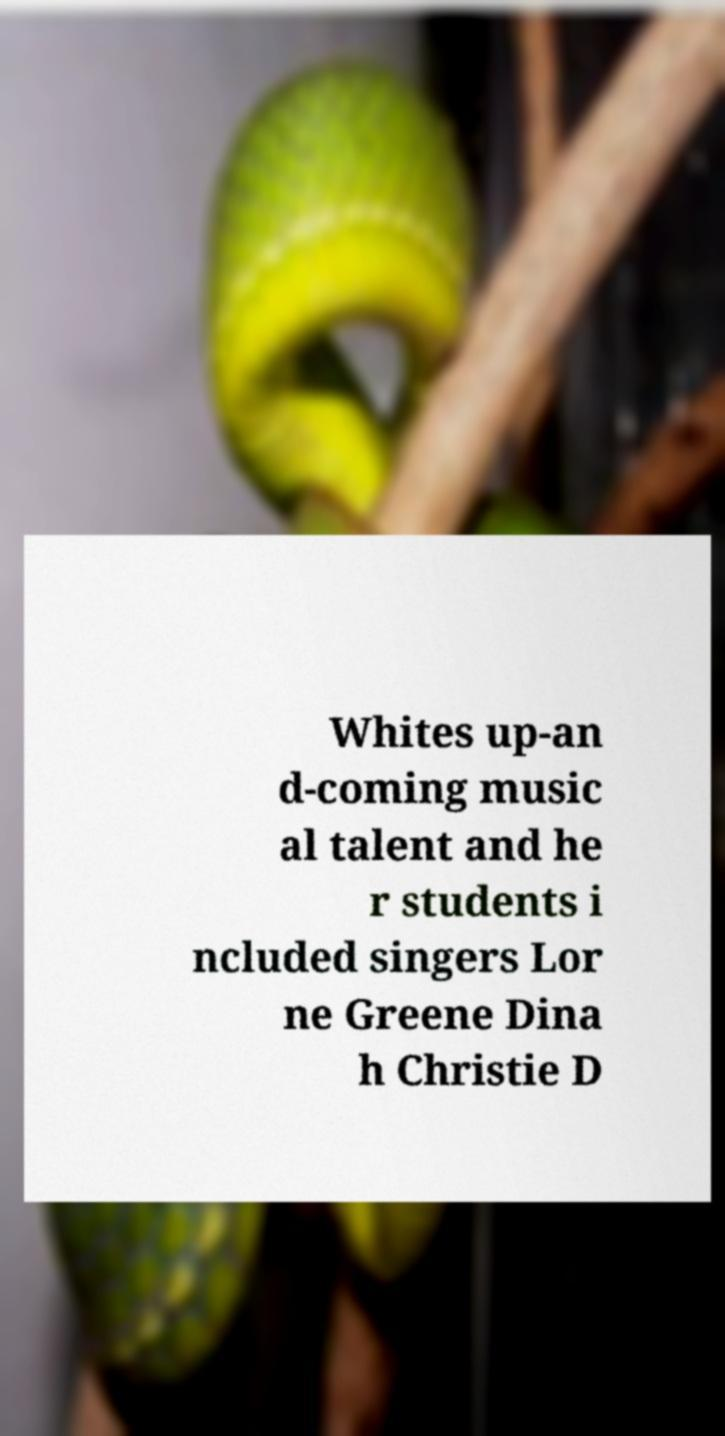I need the written content from this picture converted into text. Can you do that? Whites up-an d-coming music al talent and he r students i ncluded singers Lor ne Greene Dina h Christie D 